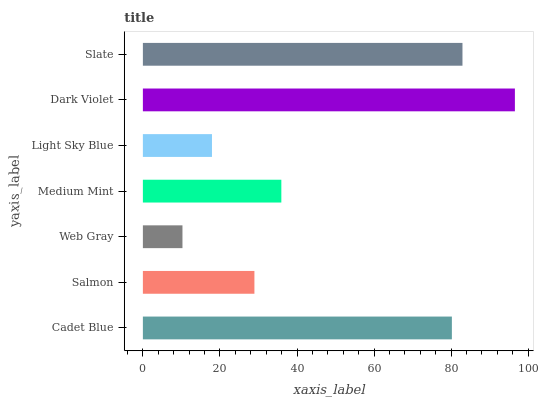Is Web Gray the minimum?
Answer yes or no. Yes. Is Dark Violet the maximum?
Answer yes or no. Yes. Is Salmon the minimum?
Answer yes or no. No. Is Salmon the maximum?
Answer yes or no. No. Is Cadet Blue greater than Salmon?
Answer yes or no. Yes. Is Salmon less than Cadet Blue?
Answer yes or no. Yes. Is Salmon greater than Cadet Blue?
Answer yes or no. No. Is Cadet Blue less than Salmon?
Answer yes or no. No. Is Medium Mint the high median?
Answer yes or no. Yes. Is Medium Mint the low median?
Answer yes or no. Yes. Is Cadet Blue the high median?
Answer yes or no. No. Is Light Sky Blue the low median?
Answer yes or no. No. 